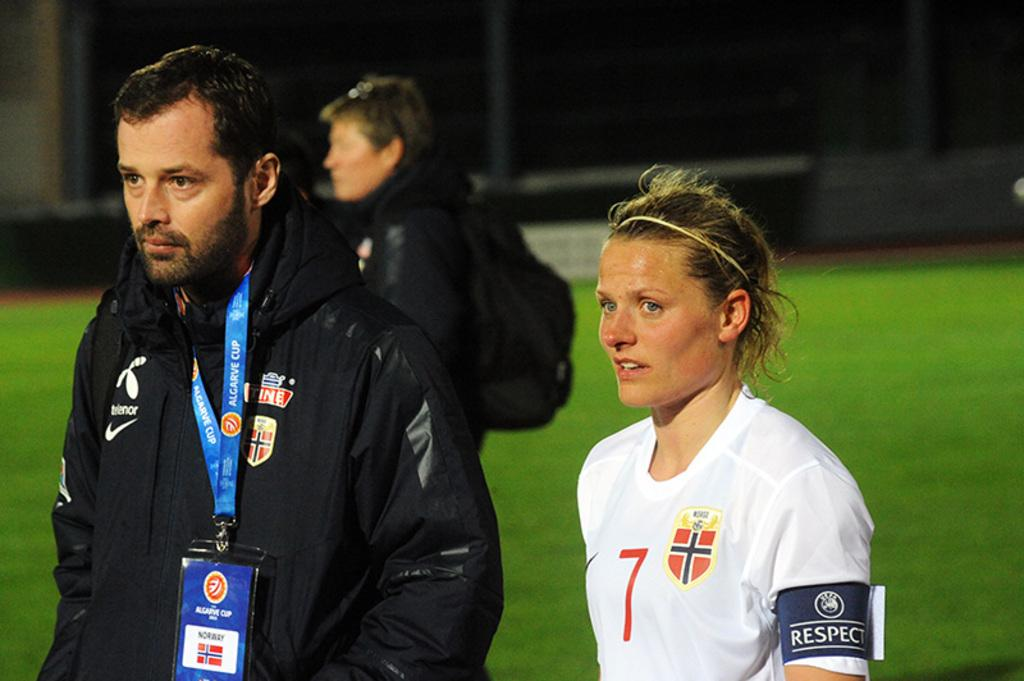<image>
Relay a brief, clear account of the picture shown. a person that has the number 7 on their soccer jersey outside 